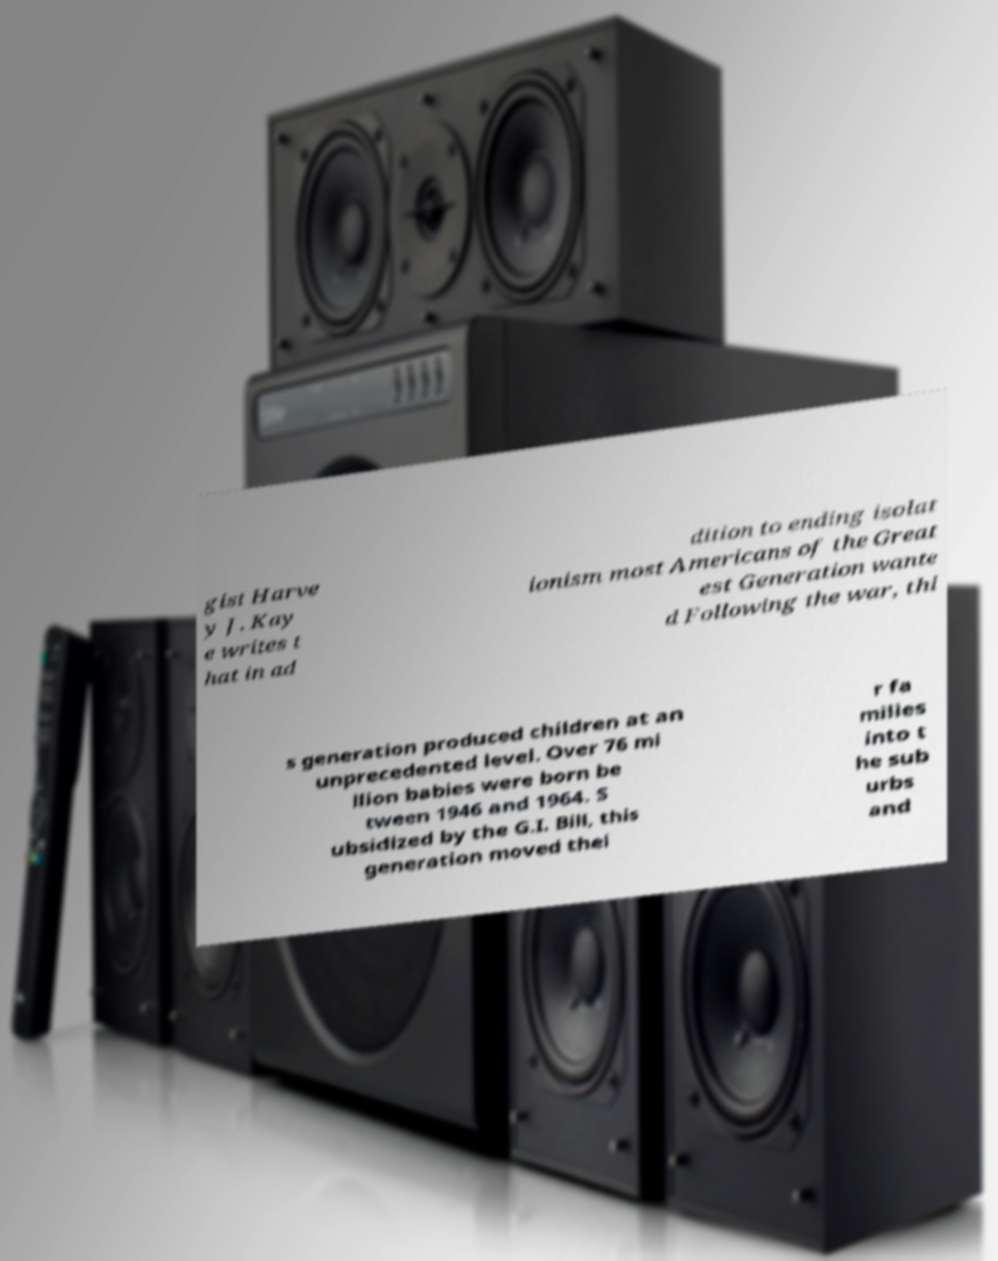There's text embedded in this image that I need extracted. Can you transcribe it verbatim? gist Harve y J. Kay e writes t hat in ad dition to ending isolat ionism most Americans of the Great est Generation wante d Following the war, thi s generation produced children at an unprecedented level. Over 76 mi llion babies were born be tween 1946 and 1964. S ubsidized by the G.I. Bill, this generation moved thei r fa milies into t he sub urbs and 